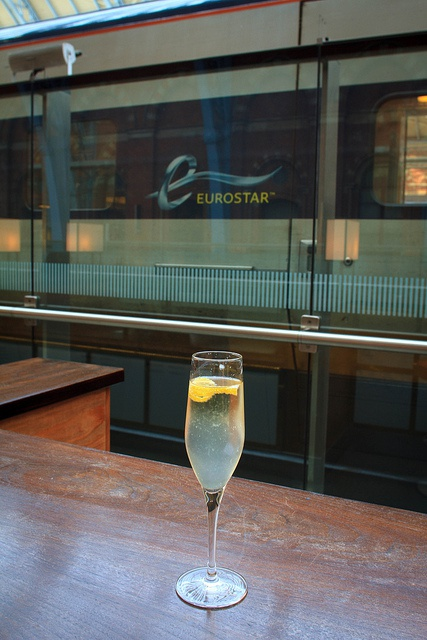Describe the objects in this image and their specific colors. I can see train in lightblue, black, gray, and teal tones, dining table in lightblue, darkgray, and gray tones, and wine glass in lightblue, darkgray, and gray tones in this image. 